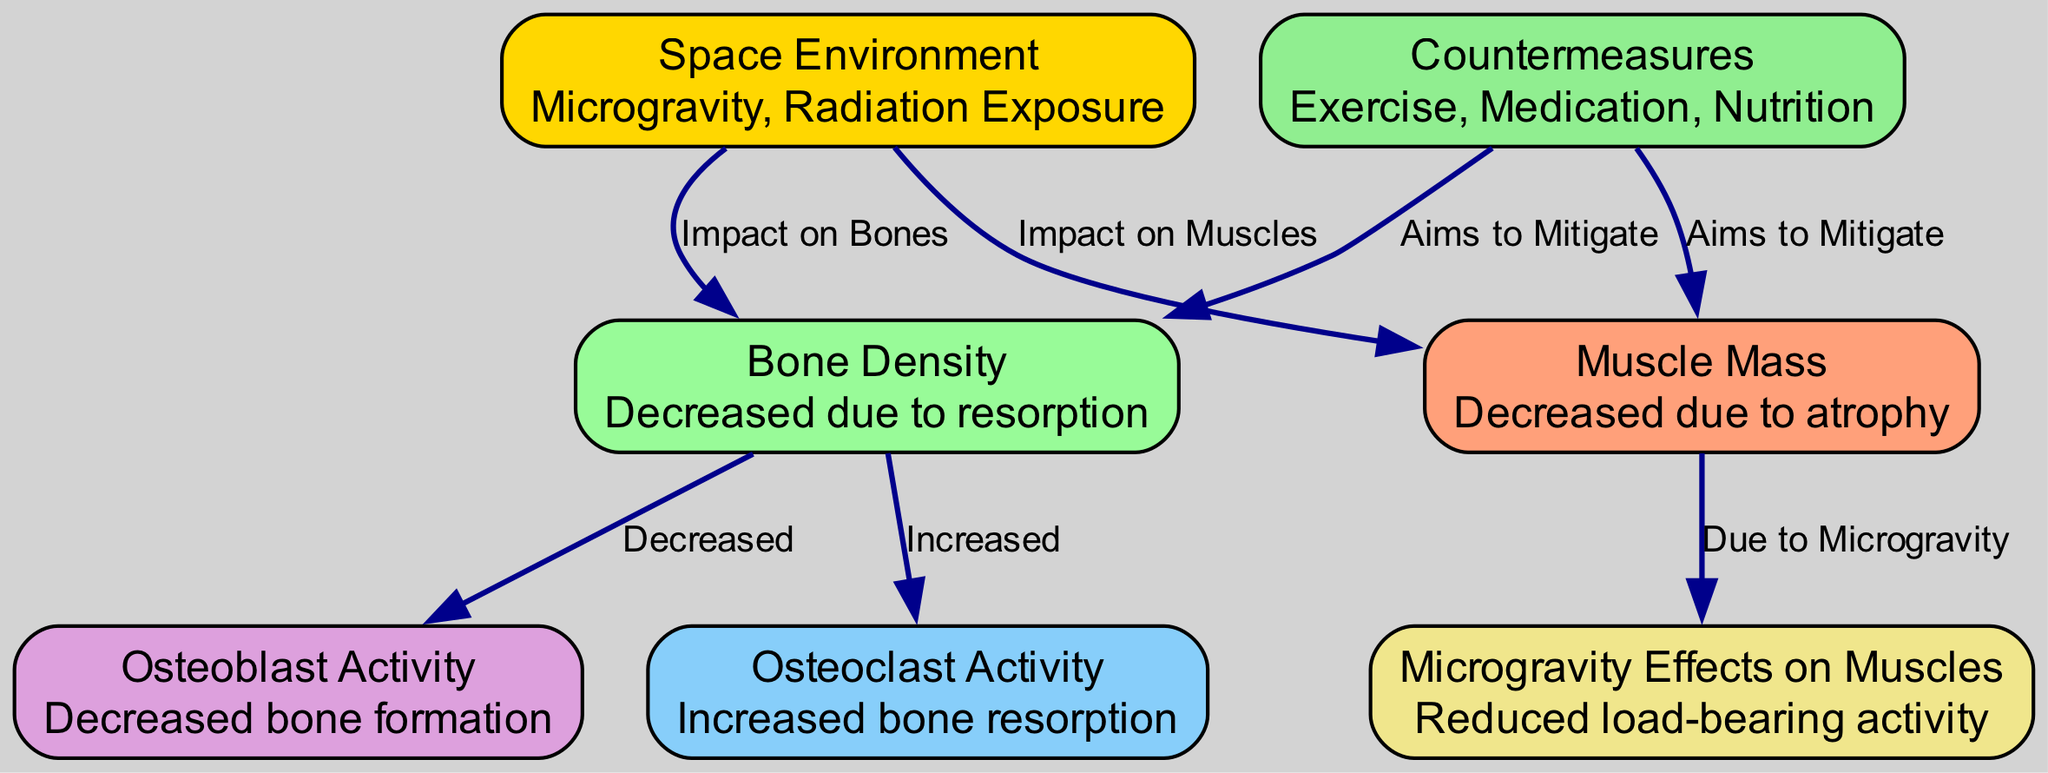What is the impact of the space environment on bone density? The diagram indicates that the space environment has an "Impact on Bones," leading to decreased bone density due to resorption.
Answer: Decreased What processes are involved in the decrease of bone density? The diagram shows two key processes: "Increased" osteoclast activity (bone resorption) and "Decreased" osteoblast activity (bone formation) affecting bone density.
Answer: Increased osteoclast activity and decreased osteoblast activity How many nodes are present in the diagram? By counting the nodes listed in the diagram, there are a total of 7 nodes related to bone density and muscle atrophy.
Answer: 7 What is the relationship between muscle mass and microgravity? The diagram illustrates that muscle mass decreases due to atrophy, which is explicitly linked to the reduced load-bearing activity in a microgravity environment.
Answer: Decreased due to atrophy What countermeasures are shown in the diagram to mitigate bone density loss? The diagram lists three countermeasures: Exercise, Medication, and Nutrition, all aiming to mitigate the effects on bone density.
Answer: Exercise, Medication, Nutrition How does the space environment affect muscle mass compared to bone density? The diagram shows that both muscle mass and bone density are negatively impacted by the space environment, but muscle mass specifically decreases due to atrophy, while bone density decreases due to resorption processes.
Answer: Both decrease; muscle mass decreases due to atrophy, bone density decreases due to resorption What is the effect of microgravity on muscle load-bearing activity? The diagram states that microgravity leads to reduced load-bearing activity, resulting in a decrease in muscle mass due to atrophy.
Answer: Reduced load-bearing activity Which node directly connects to "Countermeasures"? The diagram indicates that the countermeasures node connects directly to both bone density and muscle mass, aiming to mitigate their reductions.
Answer: Bone Density and Muscle Mass 